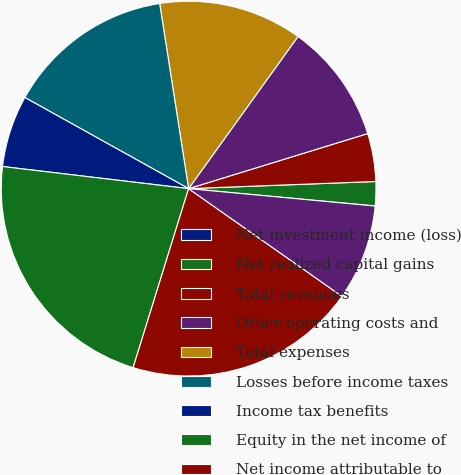<chart> <loc_0><loc_0><loc_500><loc_500><pie_chart><fcel>Net investment income (loss)<fcel>Net realized capital gains<fcel>Total revenues<fcel>Other operating costs and<fcel>Total expenses<fcel>Losses before income taxes<fcel>Income tax benefits<fcel>Equity in the net income of<fcel>Net income attributable to<fcel>Preferred stock dividends<nl><fcel>0.01%<fcel>2.08%<fcel>4.14%<fcel>10.33%<fcel>12.39%<fcel>14.45%<fcel>6.2%<fcel>22.1%<fcel>20.04%<fcel>8.26%<nl></chart> 